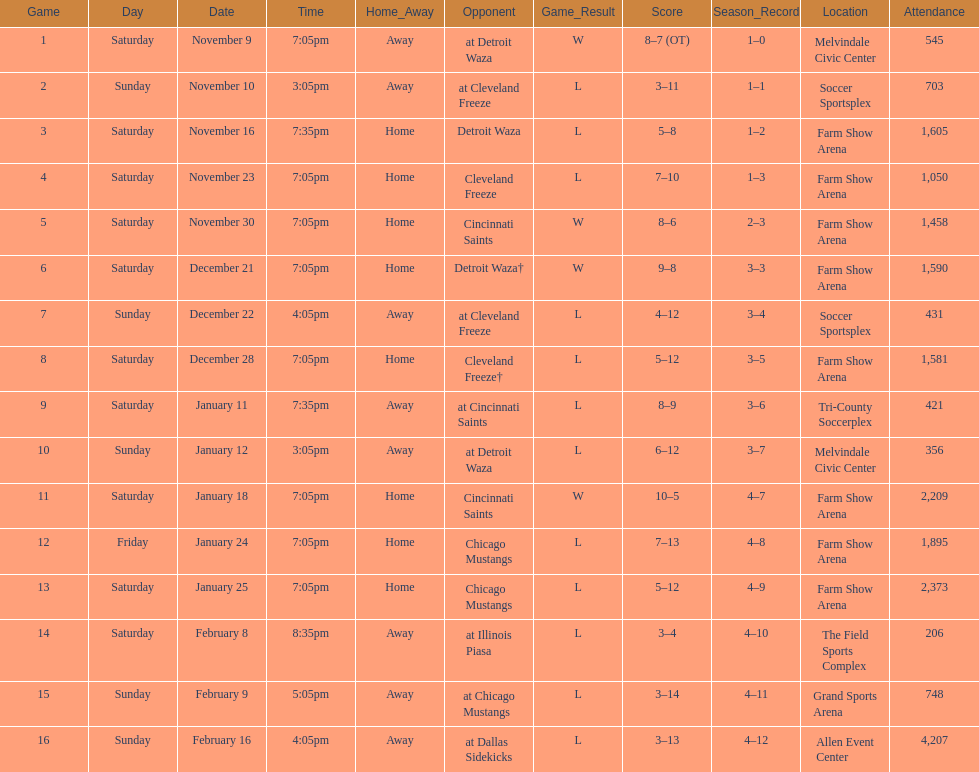How many games did the harrisburg heat win in which they scored eight or more goals? 4. 